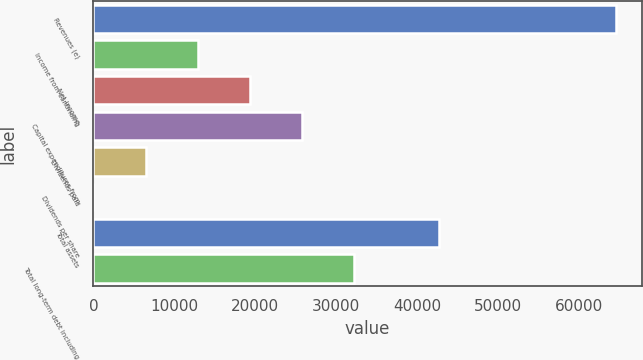Convert chart. <chart><loc_0><loc_0><loc_500><loc_500><bar_chart><fcel>Revenues (e)<fcel>Income from continuing<fcel>Net income<fcel>Capital expenditures from<fcel>Dividends paid<fcel>Dividends per share<fcel>Total assets<fcel>Total long-term debt including<nl><fcel>64552<fcel>12911.1<fcel>19366.2<fcel>25821.4<fcel>6456.03<fcel>0.92<fcel>42746<fcel>32276.5<nl></chart> 